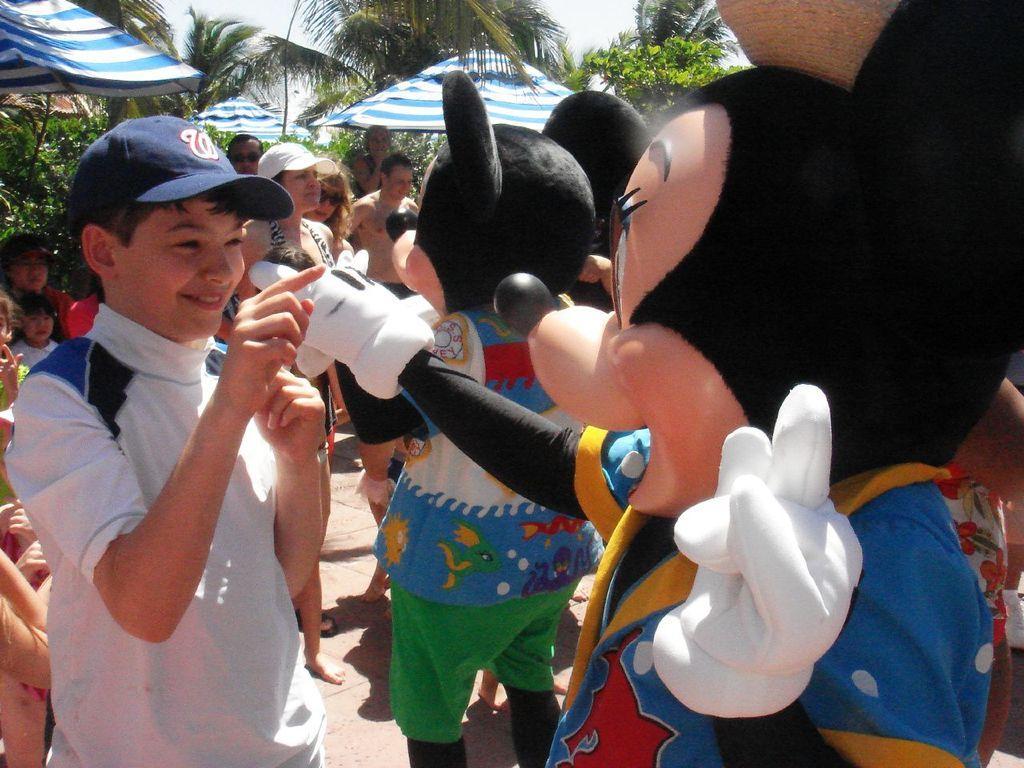Describe this image in one or two sentences. In this image we can see clowns and there are people standing. In the background there are parasols, trees and sky. 